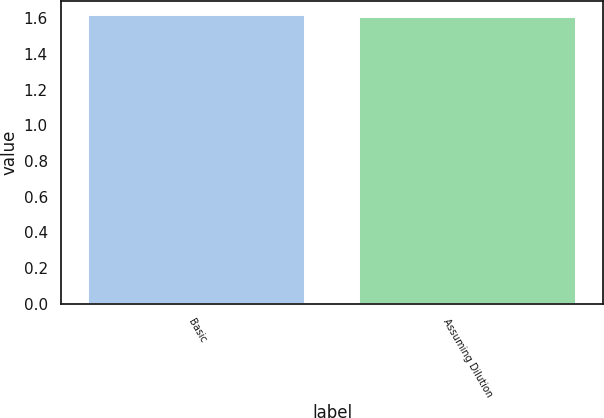Convert chart. <chart><loc_0><loc_0><loc_500><loc_500><bar_chart><fcel>Basic<fcel>Assuming Dilution<nl><fcel>1.62<fcel>1.61<nl></chart> 